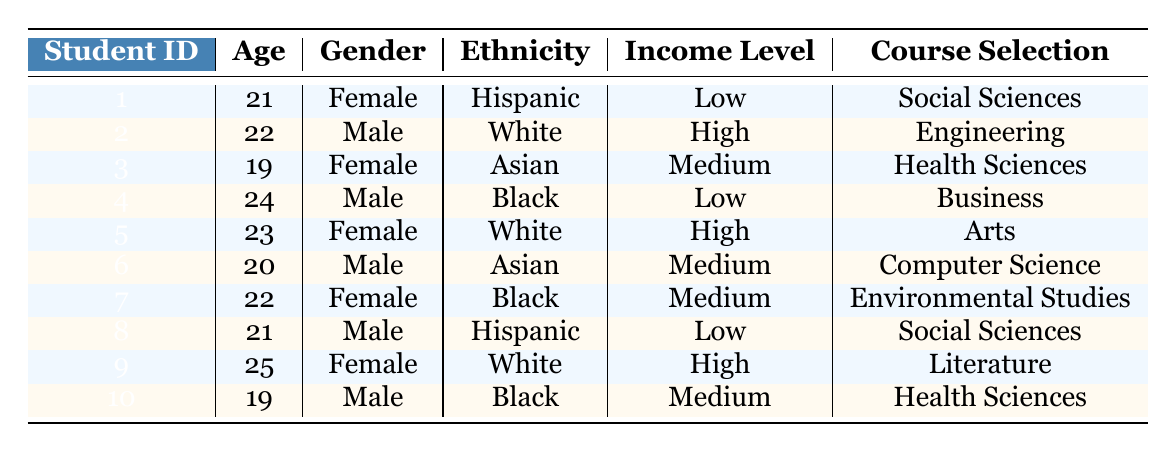what is the most common course selection among the students? The course selection column lists the courses chosen by each student. By examining the individual entries, "Social Sciences" appears twice (for students 1 and 8), while all other courses appear only once. Therefore, the most common course selection is "Social Sciences."
Answer: Social Sciences how many female students have selected Health Sciences as their course? Referencing the table, there are two entries that indicate "Health Sciences" as the selected course. Among these, the first instance pertains to student 3, who is female. The second instance is for student 10, who is male. Therefore, only one female student has selected Health Sciences.
Answer: 1 what is the average age of male students in the table? To calculate the average age of male students, we first identify the male students and their ages: Male students are students 2 (age 22), 4 (age 24), 6 (age 20), 8 (age 21), and 10 (age 19). Adding these ages gives: 22 + 24 + 20 + 21 + 19 = 106. There are 5 male students, so the average age is 106 / 5 = 21.2.
Answer: 21.2 do any students with a high income level choose Social Sciences? Looking through the table, students who have a high income level are student 2 in Engineering, student 5 in Arts, and student 9 in Literature. None of these selections are Social Sciences, confirming that no high-income students have chosen that course.
Answer: No how many students selected a course in the STEM fields (Computer Science, Engineering, Health Sciences) and how many of them are female? The following courses are classified as STEM: Computer Science (student 6), Engineering (student 2), and Health Sciences (students 3 and 10). In total, there are four students, but only one of them (student 3) is female. Thus, the results are: 4 students selected STEM courses, and 1 of them is female.
Answer: 4 students and 1 female which gender is more represented among students selecting Business courses? By examining the course selection for Business, we see that student 4 (a male) is the only entry for this course. Therefore, only male students are represented in Business.
Answer: Male 